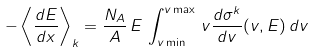Convert formula to latex. <formula><loc_0><loc_0><loc_500><loc_500>- \left \langle \frac { d E } { d x } \right \rangle _ { k } = \frac { N _ { A } } { A } \, E \, \int _ { v \min } ^ { v \max } \, v \frac { d \sigma ^ { k } } { d v } ( v , E ) \, d v</formula> 